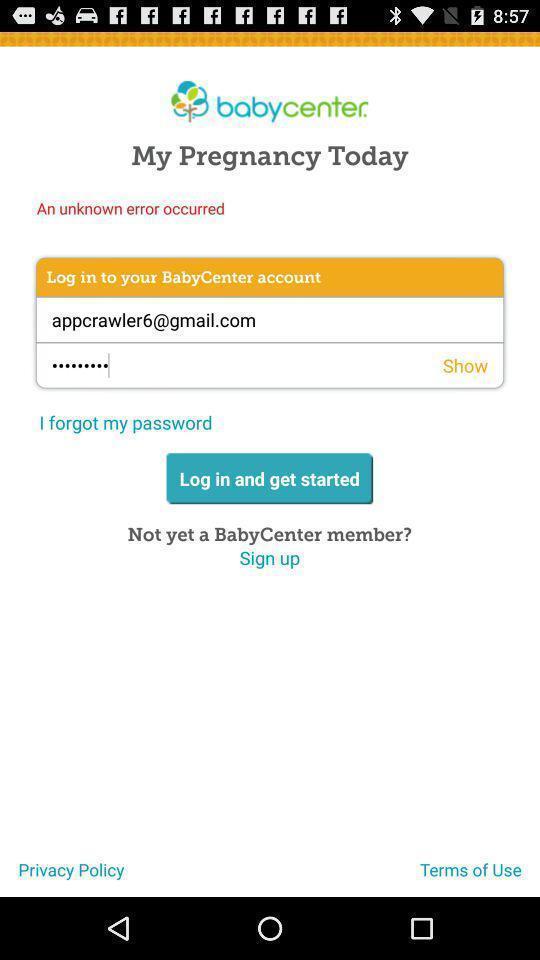Summarize the information in this screenshot. Screen displaying login page with user credentials. 